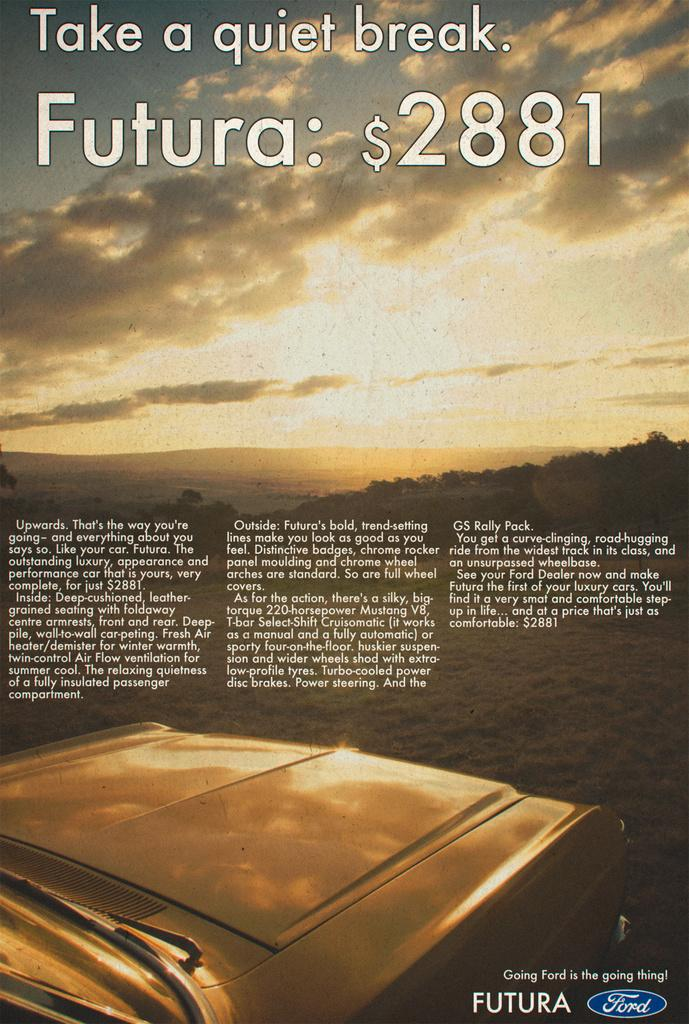<image>
Relay a brief, clear account of the picture shown. A Ford advertisement for the Futura shows it starts at $2881.00. 